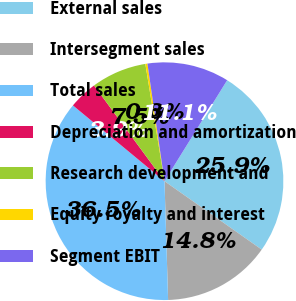Convert chart. <chart><loc_0><loc_0><loc_500><loc_500><pie_chart><fcel>External sales<fcel>Intersegment sales<fcel>Total sales<fcel>Depreciation and amortization<fcel>Research development and<fcel>Equity royalty and interest<fcel>Segment EBIT<nl><fcel>25.92%<fcel>14.76%<fcel>36.49%<fcel>3.9%<fcel>7.52%<fcel>0.28%<fcel>11.14%<nl></chart> 